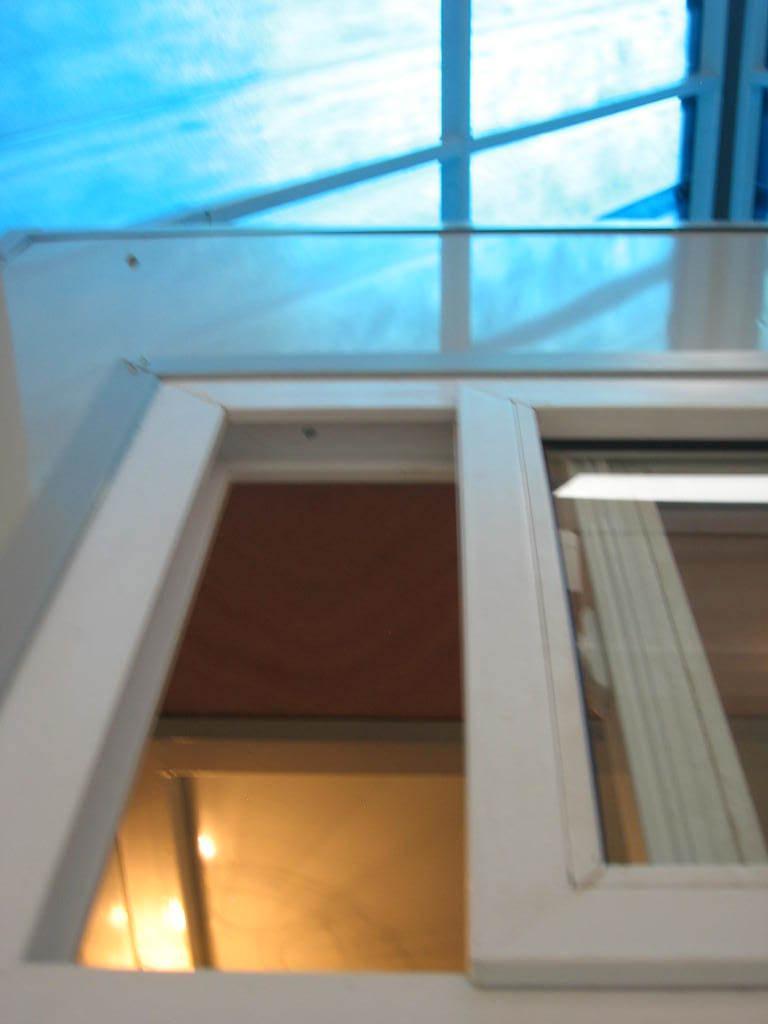Can you describe this image briefly? In this picture we can see a window with curtains, lights and in the background we can see the sky. 